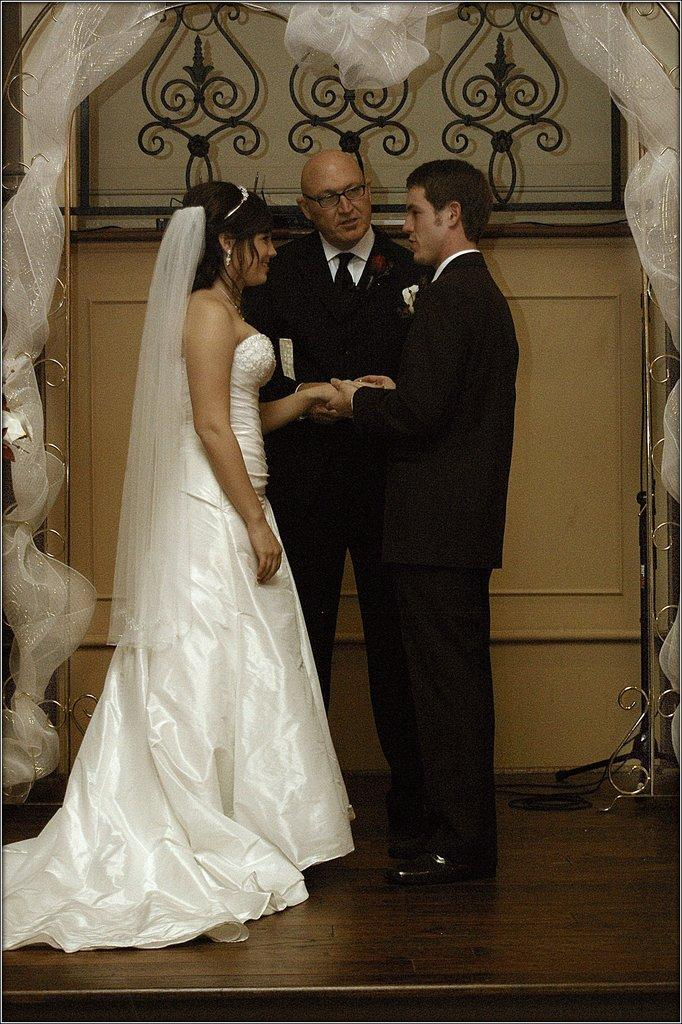Who can be seen in the image? There is a couple in the image. What is the couple doing? The person is holding the hand of the girl. Can you describe the background of the image? There is another person in the background and a wall with decoration. What invention is being demonstrated by the couple in the image? There is no invention being demonstrated by the couple in the image; they are simply holding hands. Can you tell me how many zippers are visible in the image? There are no zippers present in the image. 